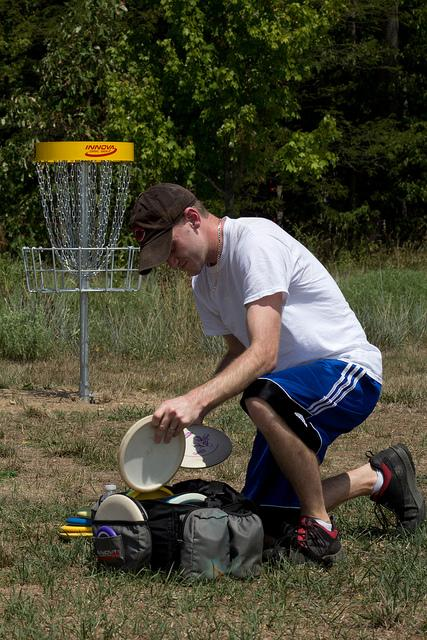The man has what on his head? Please explain your reasoning. cap. You can tell by the shape of the garment to what it is. 